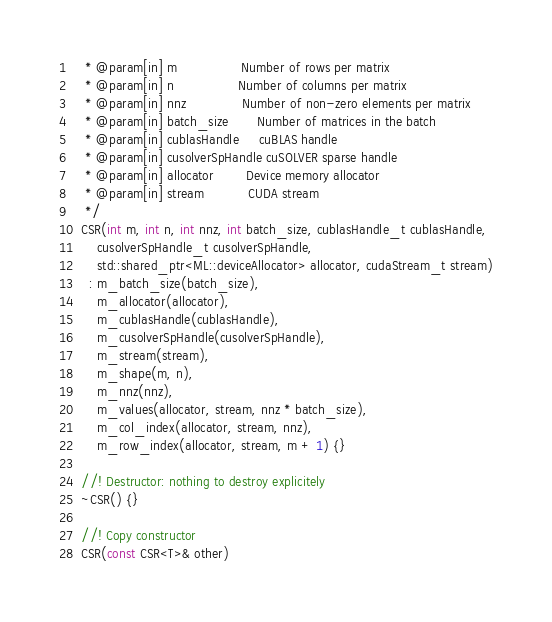<code> <loc_0><loc_0><loc_500><loc_500><_Cuda_>   * @param[in] m                Number of rows per matrix
   * @param[in] n                Number of columns per matrix
   * @param[in] nnz              Number of non-zero elements per matrix
   * @param[in] batch_size       Number of matrices in the batch
   * @param[in] cublasHandle     cuBLAS handle
   * @param[in] cusolverSpHandle cuSOLVER sparse handle
   * @param[in] allocator        Device memory allocator
   * @param[in] stream           CUDA stream
   */
  CSR(int m, int n, int nnz, int batch_size, cublasHandle_t cublasHandle,
      cusolverSpHandle_t cusolverSpHandle,
      std::shared_ptr<ML::deviceAllocator> allocator, cudaStream_t stream)
    : m_batch_size(batch_size),
      m_allocator(allocator),
      m_cublasHandle(cublasHandle),
      m_cusolverSpHandle(cusolverSpHandle),
      m_stream(stream),
      m_shape(m, n),
      m_nnz(nnz),
      m_values(allocator, stream, nnz * batch_size),
      m_col_index(allocator, stream, nnz),
      m_row_index(allocator, stream, m + 1) {}

  //! Destructor: nothing to destroy explicitely
  ~CSR() {}

  //! Copy constructor
  CSR(const CSR<T>& other)</code> 